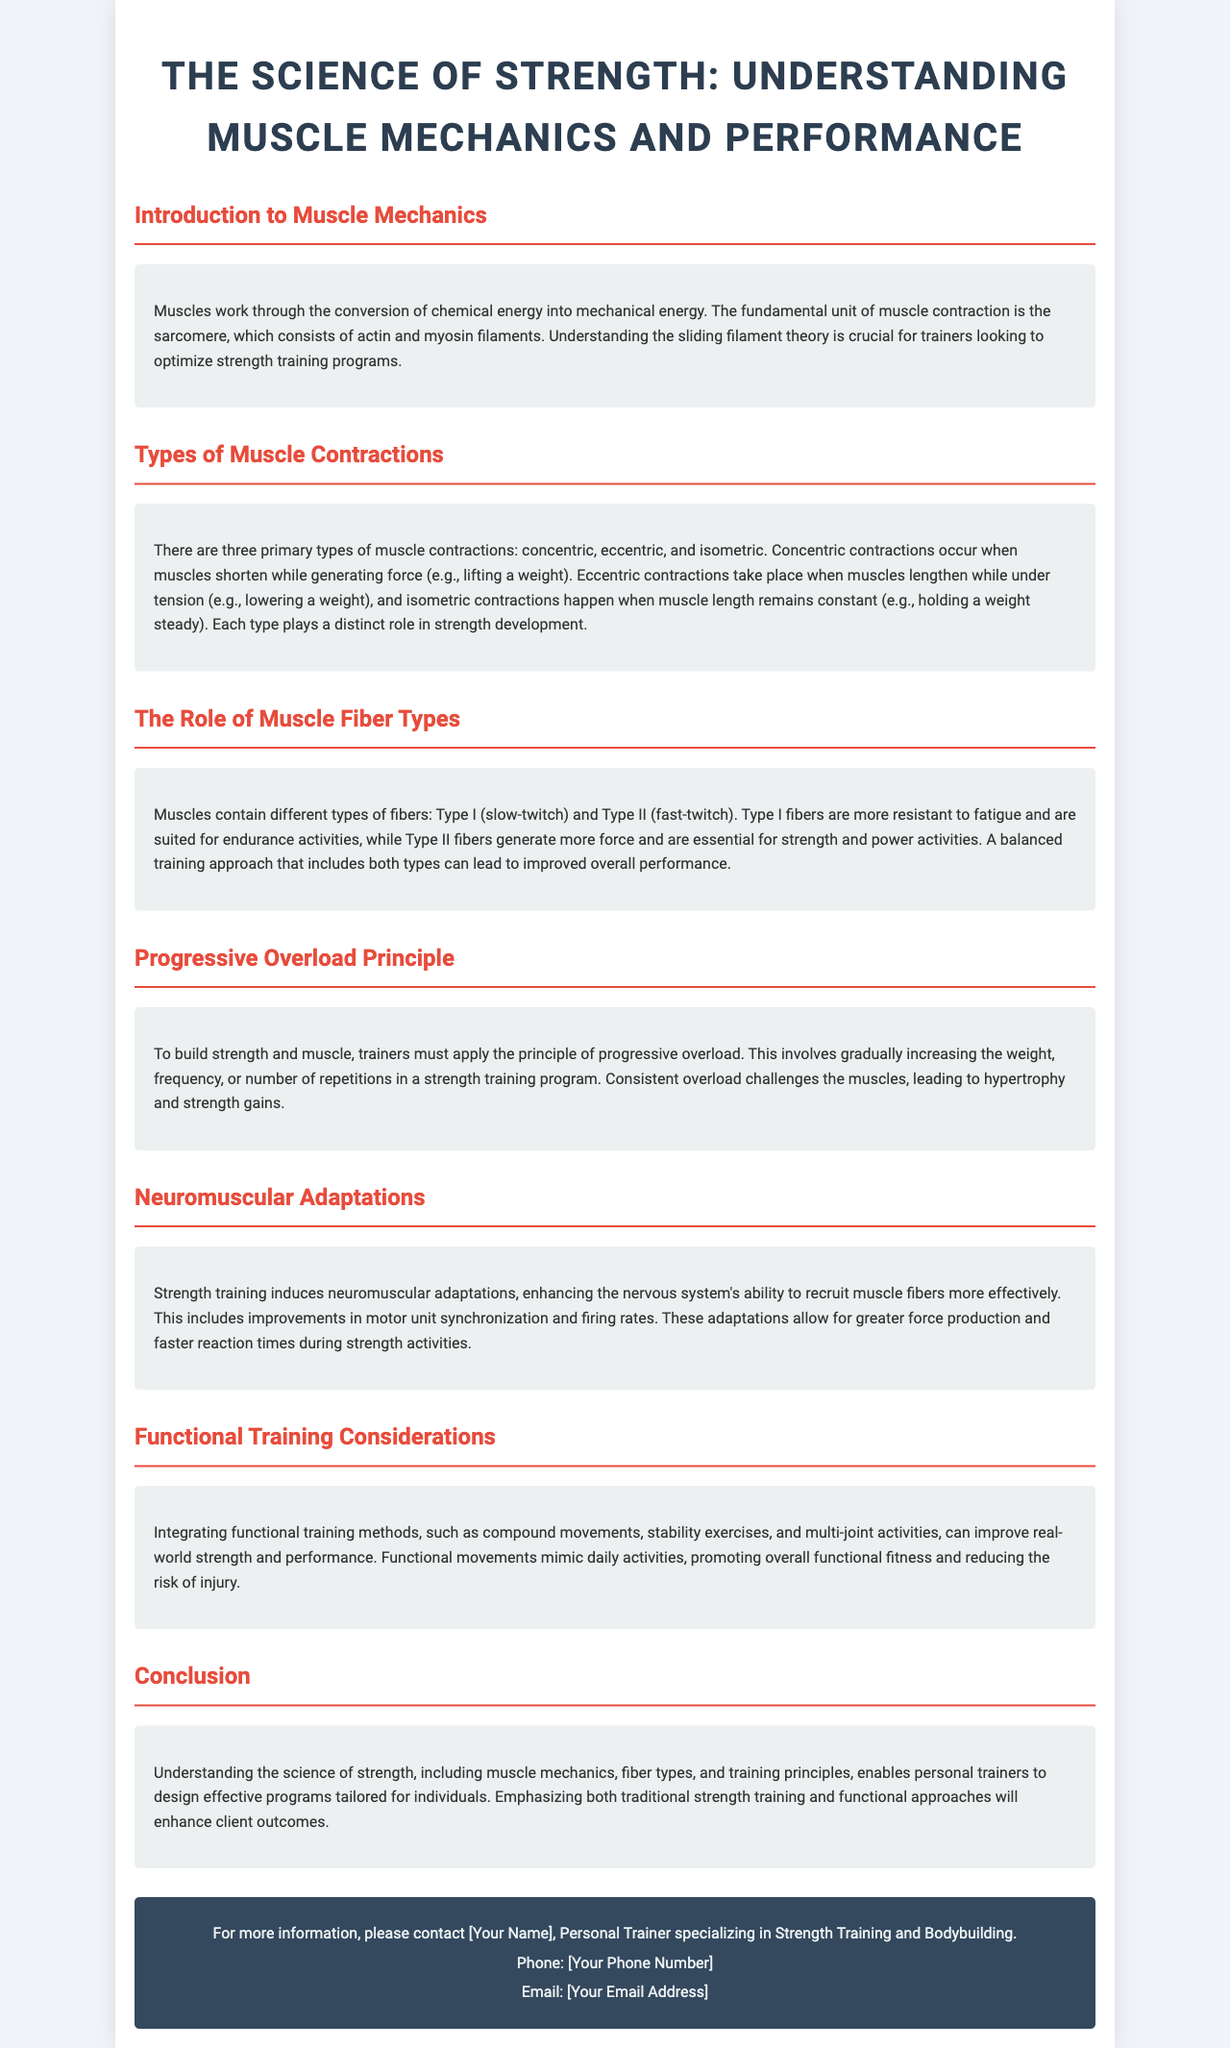What is the fundamental unit of muscle contraction? The document states that the fundamental unit of muscle contraction is the sarcomere.
Answer: sarcomere How many primary types of muscle contractions are there? The document mentions three primary types of muscle contractions: concentric, eccentric, and isometric.
Answer: three What type of muscle fibers are suited for endurance activities? According to the document, Type I fibers are more resistant to fatigue and are suited for endurance activities.
Answer: Type I What is the principle that involves gradually increasing the weight in training? The document refers to the principle of progressive overload for gradually increasing weight in training.
Answer: progressive overload What does strength training induce that enhances muscle fiber recruitment? The document discusses that strength training induces neuromuscular adaptations that enhance muscle fiber recruitment.
Answer: neuromuscular adaptations What type of training methods are mentioned in functional training considerations? The document mentions integrating functional training methods like compound movements, stability exercises, and multi-joint activities.
Answer: compound movements, stability exercises, and multi-joint activities What should trainers emphasize to enhance client outcomes? The document concludes that trainers should emphasize both traditional strength training and functional approaches.
Answer: traditional strength training and functional approaches 